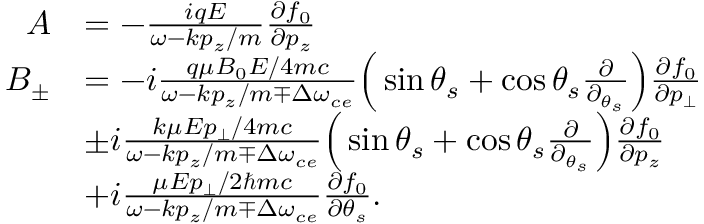Convert formula to latex. <formula><loc_0><loc_0><loc_500><loc_500>\begin{array} { r l } { A } & { = - \frac { i q E } { \omega - k p _ { z } / m } \frac { \partial f _ { 0 } } { \partial p _ { z } } } \\ { B _ { \pm } } & { = - i \frac { q \mu B _ { 0 } E / 4 m c } { \omega - k p _ { z } / m \mp \Delta \omega _ { c e } } \left ( \sin \theta _ { s } + \cos \theta _ { s } \frac { \partial } { \partial _ { \theta _ { s } } } \right ) \frac { \partial f _ { 0 } } { \partial p _ { \bot } } } \\ & { \pm i \frac { k \mu E p _ { \bot } / 4 m c } { \omega - k p _ { z } / m \mp \Delta \omega _ { c e } } \left ( \sin \theta _ { s } + \cos \theta _ { s } \frac { \partial } { \partial _ { \theta _ { s } } } \right ) \frac { \partial f _ { 0 } } { \partial p _ { z } } } \\ & { + i \frac { \mu E p _ { \bot } / 2 \hbar { m } c } { \omega - k p _ { z } / m \mp \Delta \omega _ { c e } } \frac { \partial f _ { 0 } } { \partial \theta _ { s } } . } \end{array}</formula> 